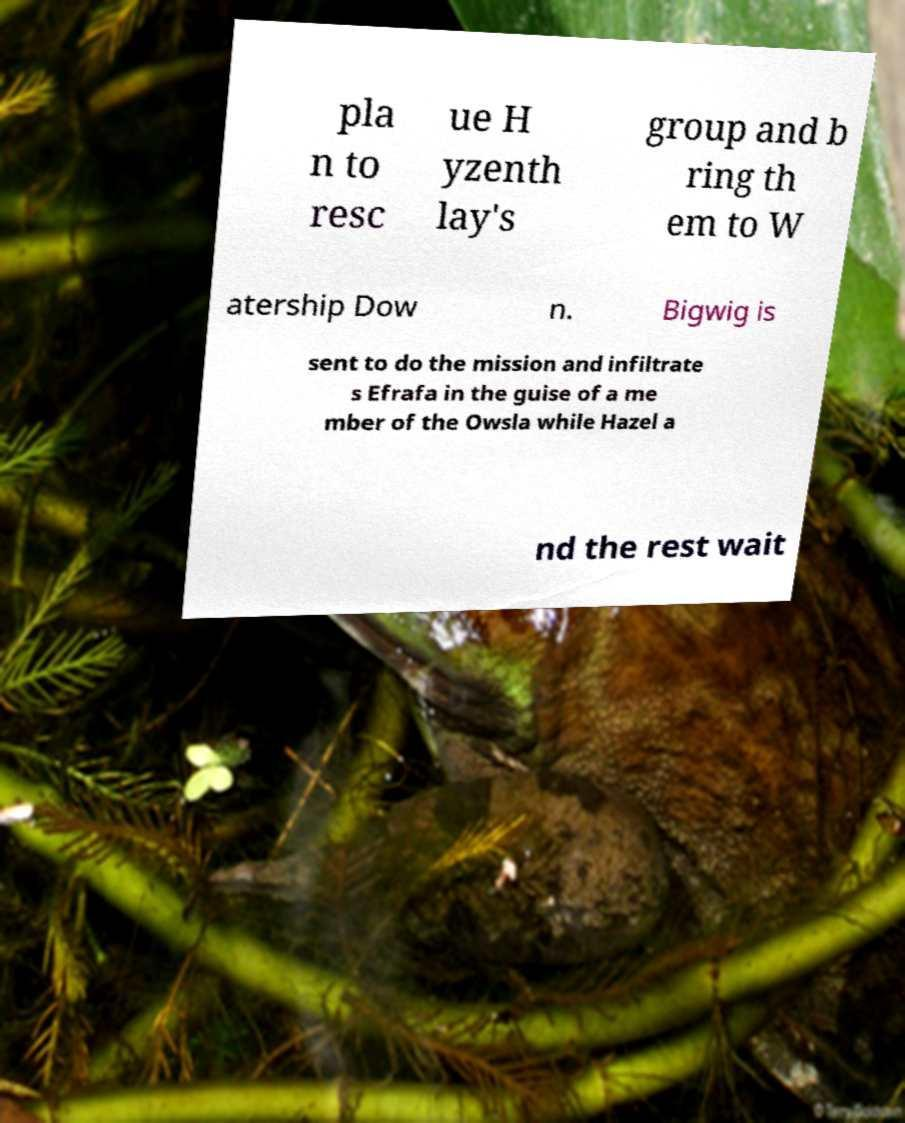Can you accurately transcribe the text from the provided image for me? pla n to resc ue H yzenth lay's group and b ring th em to W atership Dow n. Bigwig is sent to do the mission and infiltrate s Efrafa in the guise of a me mber of the Owsla while Hazel a nd the rest wait 